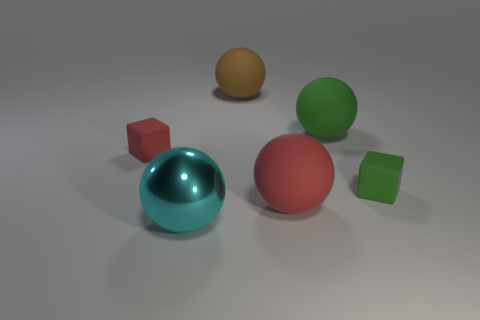What number of other things are there of the same color as the large metal ball?
Offer a very short reply. 0. Are there any other things that have the same material as the cyan thing?
Give a very brief answer. No. The cyan shiny object is what shape?
Give a very brief answer. Sphere. Are there more large red things in front of the big shiny object than big balls?
Give a very brief answer. No. Does the small red matte thing have the same shape as the object that is right of the big green sphere?
Ensure brevity in your answer.  Yes. Are any large balls visible?
Ensure brevity in your answer.  Yes. What number of large objects are either metal spheres or rubber objects?
Provide a short and direct response. 4. Is the number of small matte objects that are on the left side of the metal sphere greater than the number of green cubes that are in front of the large red matte thing?
Make the answer very short. Yes. Does the small green cube have the same material as the red block behind the large cyan sphere?
Give a very brief answer. Yes. There is a green object that is behind the tiny green rubber cube; what shape is it?
Your answer should be compact. Sphere. 